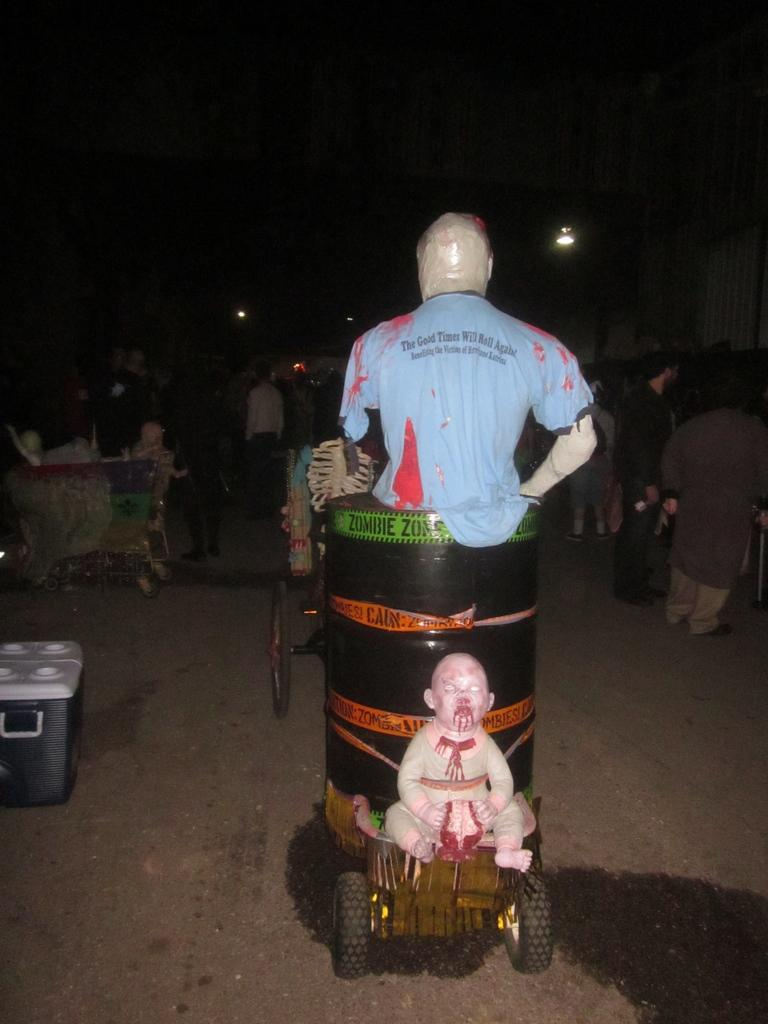What is the main subject in the image? There is a statue in the image. What is the color of the statue? The statue is white in color. What can be seen on the left side of the image? There is a grey color container on the left side of the image. What is visible in the background of the image? There are people standing in the background of the image. What attempt did the statue's creator make to improve the statue's design? There is no information about the statue's creator or any attempts to improve the design in the image. 